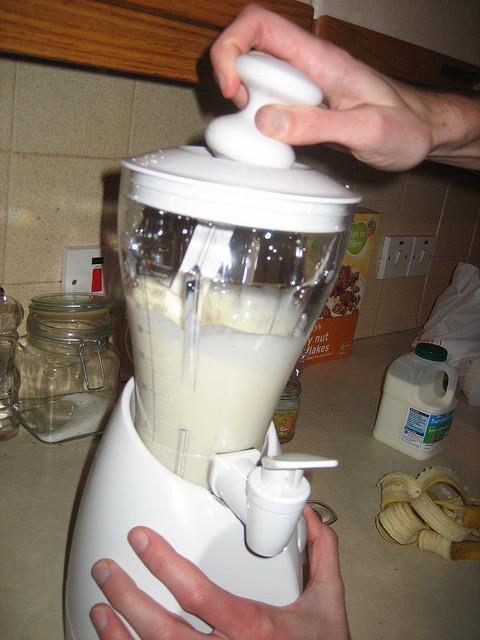How many people can be seen?
Give a very brief answer. 2. 